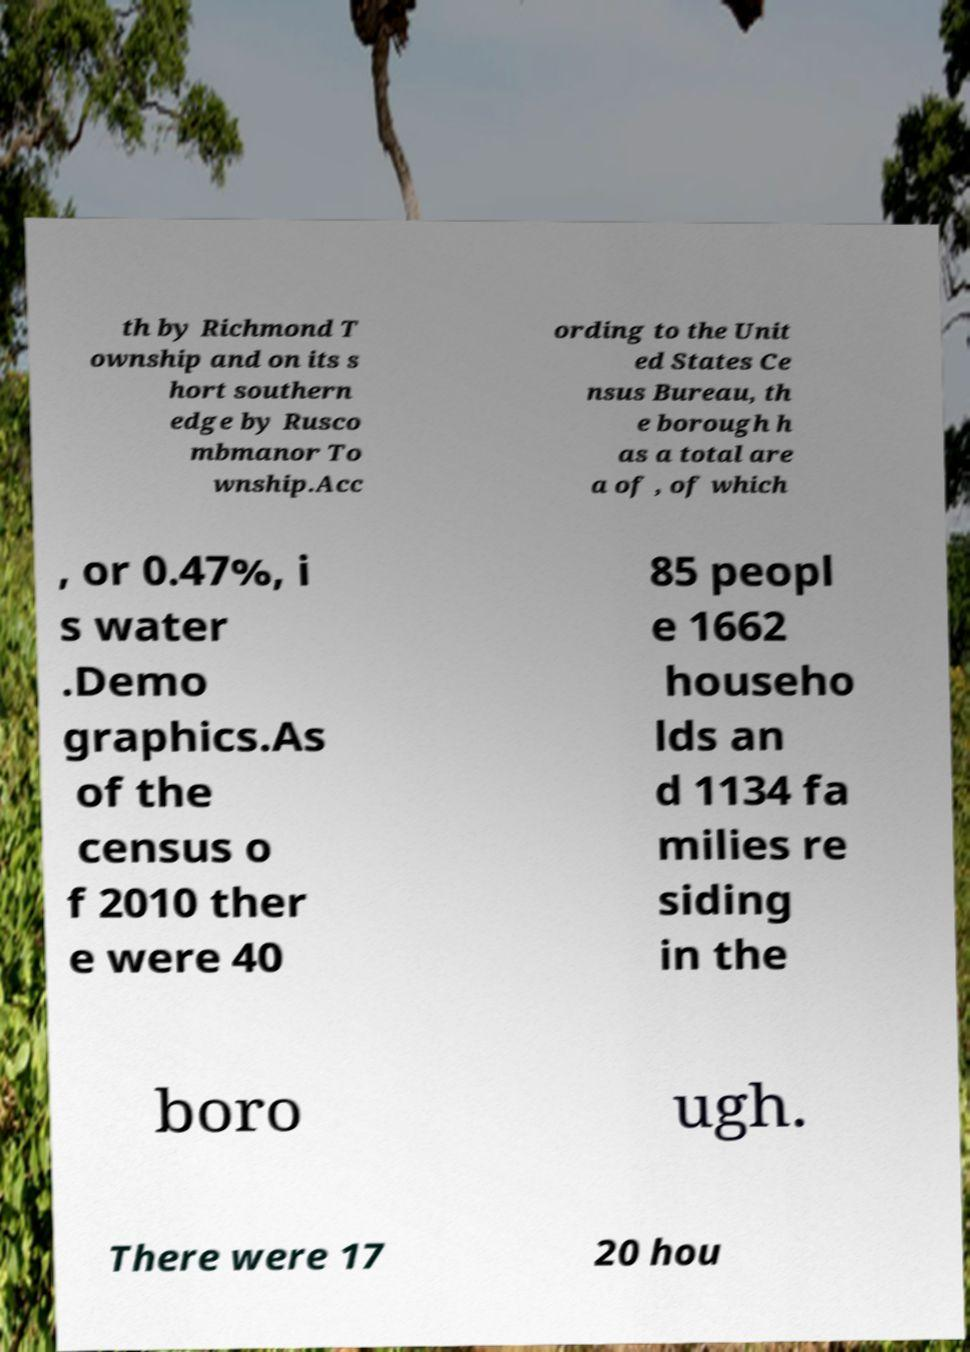I need the written content from this picture converted into text. Can you do that? th by Richmond T ownship and on its s hort southern edge by Rusco mbmanor To wnship.Acc ording to the Unit ed States Ce nsus Bureau, th e borough h as a total are a of , of which , or 0.47%, i s water .Demo graphics.As of the census o f 2010 ther e were 40 85 peopl e 1662 househo lds an d 1134 fa milies re siding in the boro ugh. There were 17 20 hou 